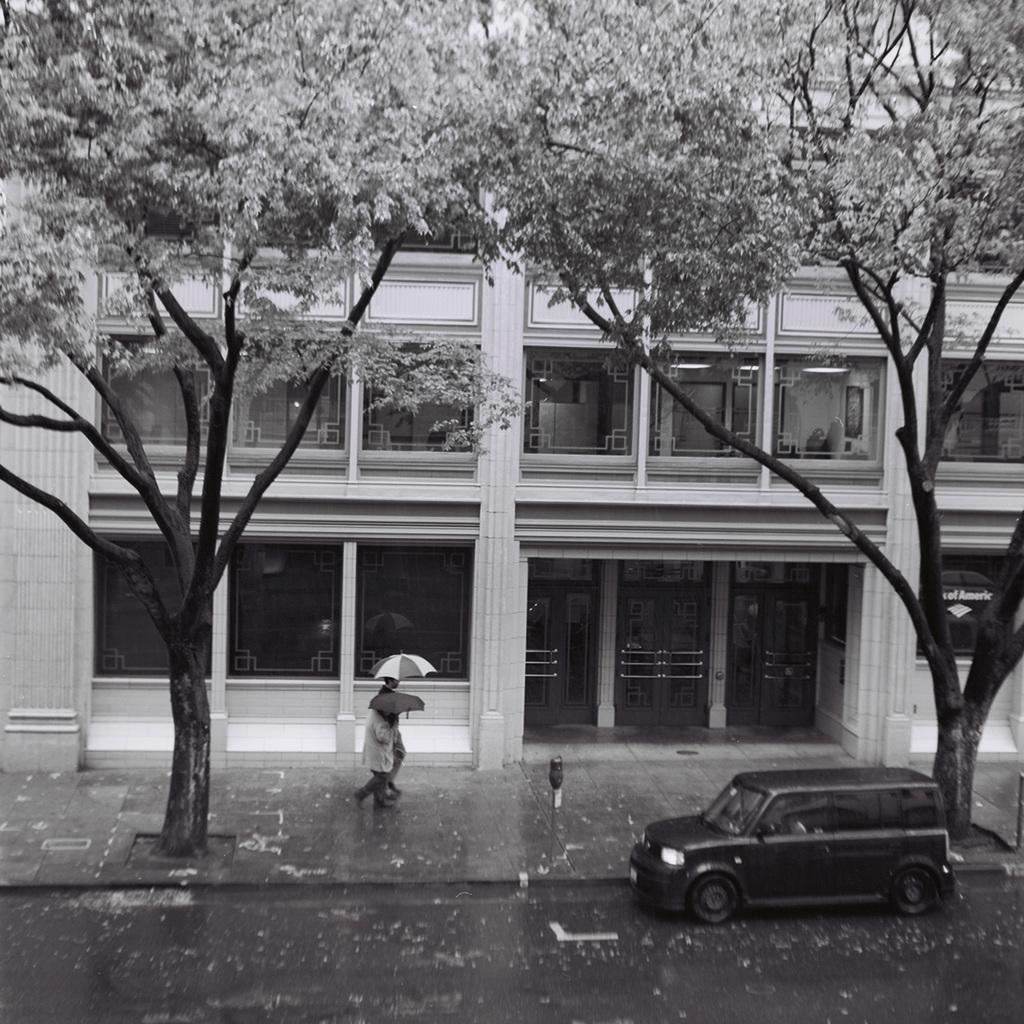What is the color scheme of the image? The image is black and white. What are the persons in the image doing? The persons in the image are walking. What are the persons holding while walking? The persons are holding umbrellas. What type of vegetation is present in the image? There are trees in the image. What type of man-made structure is visible in the image? There is a vehicle in the image. What can be seen in the background of the image? There is a building in the background of the image. How many stars can be seen in the image? There are no stars visible in the image, as it is a black and white image of persons walking with umbrellas. What is the distance between the persons and the building in the image? The distance between the persons and the building cannot be determined from the image, as there is no scale or reference point provided. 